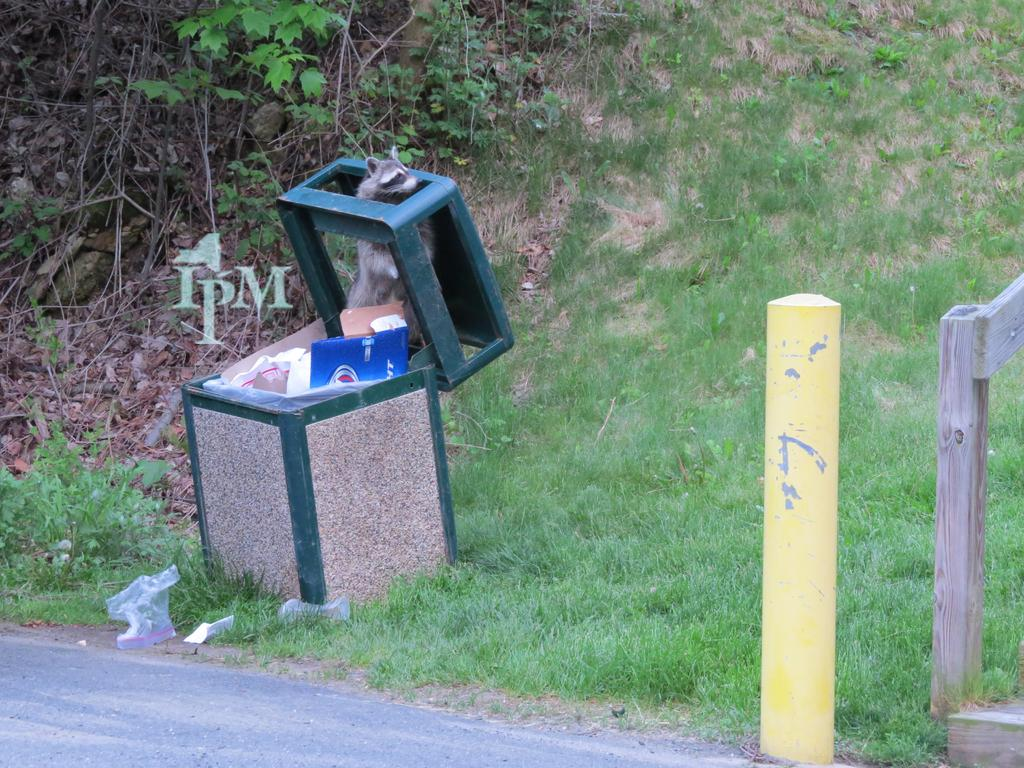What object is present in the image that is typically used for waste disposal? There is a dustbin in the image. What is the small, vertical object in the image? There is a small pole in the image. What type of vegetation can be seen in the image? There is grass and plants in the image. What type of surface is visible at the bottom of the image? The bottom of the image contains a road. What feature can be seen on the right side of the image that might be used for safety or support? There appears to be a railing on the right side of the image. How does the thumb contribute to the image? There is no thumb present in the image. What type of pump is visible in the image? There is no pump present in the image. 